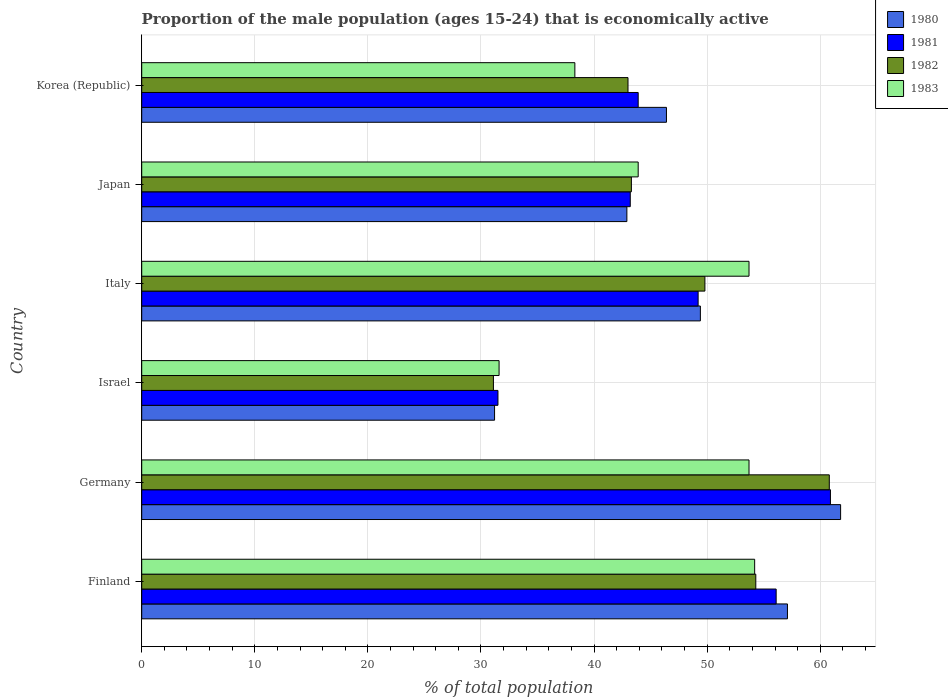How many groups of bars are there?
Ensure brevity in your answer.  6. Are the number of bars per tick equal to the number of legend labels?
Provide a succinct answer. Yes. How many bars are there on the 2nd tick from the top?
Make the answer very short. 4. How many bars are there on the 3rd tick from the bottom?
Ensure brevity in your answer.  4. What is the label of the 4th group of bars from the top?
Your answer should be compact. Israel. In how many cases, is the number of bars for a given country not equal to the number of legend labels?
Keep it short and to the point. 0. Across all countries, what is the maximum proportion of the male population that is economically active in 1982?
Ensure brevity in your answer.  60.8. Across all countries, what is the minimum proportion of the male population that is economically active in 1983?
Your answer should be very brief. 31.6. In which country was the proportion of the male population that is economically active in 1983 minimum?
Ensure brevity in your answer.  Israel. What is the total proportion of the male population that is economically active in 1981 in the graph?
Make the answer very short. 284.8. What is the difference between the proportion of the male population that is economically active in 1982 in Italy and that in Korea (Republic)?
Your answer should be very brief. 6.8. What is the difference between the proportion of the male population that is economically active in 1980 in Israel and the proportion of the male population that is economically active in 1981 in Germany?
Keep it short and to the point. -29.7. What is the average proportion of the male population that is economically active in 1983 per country?
Provide a short and direct response. 45.9. What is the difference between the proportion of the male population that is economically active in 1980 and proportion of the male population that is economically active in 1981 in Finland?
Keep it short and to the point. 1. In how many countries, is the proportion of the male population that is economically active in 1982 greater than 34 %?
Keep it short and to the point. 5. What is the ratio of the proportion of the male population that is economically active in 1982 in Germany to that in Italy?
Offer a terse response. 1.22. Is the proportion of the male population that is economically active in 1980 in Germany less than that in Italy?
Offer a terse response. No. Is the difference between the proportion of the male population that is economically active in 1980 in Germany and Italy greater than the difference between the proportion of the male population that is economically active in 1981 in Germany and Italy?
Offer a very short reply. Yes. What is the difference between the highest and the second highest proportion of the male population that is economically active in 1982?
Give a very brief answer. 6.5. What is the difference between the highest and the lowest proportion of the male population that is economically active in 1982?
Provide a succinct answer. 29.7. Is the sum of the proportion of the male population that is economically active in 1983 in Finland and Japan greater than the maximum proportion of the male population that is economically active in 1982 across all countries?
Your answer should be very brief. Yes. Is it the case that in every country, the sum of the proportion of the male population that is economically active in 1982 and proportion of the male population that is economically active in 1983 is greater than the sum of proportion of the male population that is economically active in 1981 and proportion of the male population that is economically active in 1980?
Offer a terse response. No. What does the 4th bar from the top in Finland represents?
Ensure brevity in your answer.  1980. What does the 2nd bar from the bottom in Korea (Republic) represents?
Your answer should be very brief. 1981. How many bars are there?
Offer a very short reply. 24. Are all the bars in the graph horizontal?
Keep it short and to the point. Yes. What is the difference between two consecutive major ticks on the X-axis?
Give a very brief answer. 10. Are the values on the major ticks of X-axis written in scientific E-notation?
Your answer should be very brief. No. How many legend labels are there?
Offer a very short reply. 4. How are the legend labels stacked?
Offer a very short reply. Vertical. What is the title of the graph?
Ensure brevity in your answer.  Proportion of the male population (ages 15-24) that is economically active. What is the label or title of the X-axis?
Offer a very short reply. % of total population. What is the % of total population in 1980 in Finland?
Provide a succinct answer. 57.1. What is the % of total population of 1981 in Finland?
Provide a succinct answer. 56.1. What is the % of total population in 1982 in Finland?
Ensure brevity in your answer.  54.3. What is the % of total population in 1983 in Finland?
Offer a terse response. 54.2. What is the % of total population of 1980 in Germany?
Offer a very short reply. 61.8. What is the % of total population in 1981 in Germany?
Your response must be concise. 60.9. What is the % of total population of 1982 in Germany?
Make the answer very short. 60.8. What is the % of total population of 1983 in Germany?
Offer a very short reply. 53.7. What is the % of total population of 1980 in Israel?
Ensure brevity in your answer.  31.2. What is the % of total population of 1981 in Israel?
Offer a terse response. 31.5. What is the % of total population of 1982 in Israel?
Offer a terse response. 31.1. What is the % of total population in 1983 in Israel?
Provide a short and direct response. 31.6. What is the % of total population of 1980 in Italy?
Make the answer very short. 49.4. What is the % of total population of 1981 in Italy?
Your answer should be compact. 49.2. What is the % of total population of 1982 in Italy?
Provide a short and direct response. 49.8. What is the % of total population of 1983 in Italy?
Offer a terse response. 53.7. What is the % of total population of 1980 in Japan?
Your answer should be very brief. 42.9. What is the % of total population of 1981 in Japan?
Offer a very short reply. 43.2. What is the % of total population of 1982 in Japan?
Ensure brevity in your answer.  43.3. What is the % of total population in 1983 in Japan?
Provide a short and direct response. 43.9. What is the % of total population in 1980 in Korea (Republic)?
Your answer should be compact. 46.4. What is the % of total population in 1981 in Korea (Republic)?
Offer a very short reply. 43.9. What is the % of total population in 1982 in Korea (Republic)?
Give a very brief answer. 43. What is the % of total population in 1983 in Korea (Republic)?
Offer a terse response. 38.3. Across all countries, what is the maximum % of total population of 1980?
Provide a succinct answer. 61.8. Across all countries, what is the maximum % of total population in 1981?
Provide a short and direct response. 60.9. Across all countries, what is the maximum % of total population in 1982?
Ensure brevity in your answer.  60.8. Across all countries, what is the maximum % of total population in 1983?
Keep it short and to the point. 54.2. Across all countries, what is the minimum % of total population in 1980?
Provide a short and direct response. 31.2. Across all countries, what is the minimum % of total population in 1981?
Make the answer very short. 31.5. Across all countries, what is the minimum % of total population of 1982?
Provide a succinct answer. 31.1. Across all countries, what is the minimum % of total population in 1983?
Provide a succinct answer. 31.6. What is the total % of total population in 1980 in the graph?
Provide a succinct answer. 288.8. What is the total % of total population in 1981 in the graph?
Offer a very short reply. 284.8. What is the total % of total population in 1982 in the graph?
Your response must be concise. 282.3. What is the total % of total population in 1983 in the graph?
Offer a very short reply. 275.4. What is the difference between the % of total population in 1980 in Finland and that in Germany?
Your answer should be very brief. -4.7. What is the difference between the % of total population in 1981 in Finland and that in Germany?
Your answer should be compact. -4.8. What is the difference between the % of total population of 1983 in Finland and that in Germany?
Your answer should be very brief. 0.5. What is the difference between the % of total population in 1980 in Finland and that in Israel?
Make the answer very short. 25.9. What is the difference between the % of total population of 1981 in Finland and that in Israel?
Make the answer very short. 24.6. What is the difference between the % of total population in 1982 in Finland and that in Israel?
Make the answer very short. 23.2. What is the difference between the % of total population in 1983 in Finland and that in Israel?
Keep it short and to the point. 22.6. What is the difference between the % of total population in 1982 in Finland and that in Italy?
Offer a terse response. 4.5. What is the difference between the % of total population in 1983 in Finland and that in Italy?
Offer a terse response. 0.5. What is the difference between the % of total population of 1980 in Finland and that in Korea (Republic)?
Ensure brevity in your answer.  10.7. What is the difference between the % of total population of 1981 in Finland and that in Korea (Republic)?
Offer a terse response. 12.2. What is the difference between the % of total population of 1980 in Germany and that in Israel?
Provide a short and direct response. 30.6. What is the difference between the % of total population in 1981 in Germany and that in Israel?
Provide a succinct answer. 29.4. What is the difference between the % of total population in 1982 in Germany and that in Israel?
Give a very brief answer. 29.7. What is the difference between the % of total population in 1983 in Germany and that in Israel?
Your answer should be compact. 22.1. What is the difference between the % of total population in 1980 in Germany and that in Italy?
Provide a short and direct response. 12.4. What is the difference between the % of total population in 1982 in Germany and that in Italy?
Provide a succinct answer. 11. What is the difference between the % of total population in 1983 in Germany and that in Italy?
Give a very brief answer. 0. What is the difference between the % of total population in 1982 in Germany and that in Japan?
Your answer should be very brief. 17.5. What is the difference between the % of total population in 1983 in Germany and that in Japan?
Your response must be concise. 9.8. What is the difference between the % of total population in 1980 in Germany and that in Korea (Republic)?
Provide a succinct answer. 15.4. What is the difference between the % of total population in 1982 in Germany and that in Korea (Republic)?
Give a very brief answer. 17.8. What is the difference between the % of total population of 1980 in Israel and that in Italy?
Provide a short and direct response. -18.2. What is the difference between the % of total population of 1981 in Israel and that in Italy?
Offer a very short reply. -17.7. What is the difference between the % of total population in 1982 in Israel and that in Italy?
Your response must be concise. -18.7. What is the difference between the % of total population of 1983 in Israel and that in Italy?
Ensure brevity in your answer.  -22.1. What is the difference between the % of total population in 1981 in Israel and that in Japan?
Provide a short and direct response. -11.7. What is the difference between the % of total population of 1982 in Israel and that in Japan?
Your answer should be very brief. -12.2. What is the difference between the % of total population of 1983 in Israel and that in Japan?
Provide a succinct answer. -12.3. What is the difference between the % of total population in 1980 in Israel and that in Korea (Republic)?
Ensure brevity in your answer.  -15.2. What is the difference between the % of total population of 1981 in Israel and that in Korea (Republic)?
Your answer should be compact. -12.4. What is the difference between the % of total population in 1982 in Israel and that in Korea (Republic)?
Your response must be concise. -11.9. What is the difference between the % of total population in 1981 in Italy and that in Japan?
Provide a succinct answer. 6. What is the difference between the % of total population in 1982 in Italy and that in Japan?
Provide a short and direct response. 6.5. What is the difference between the % of total population of 1980 in Italy and that in Korea (Republic)?
Your answer should be very brief. 3. What is the difference between the % of total population of 1981 in Italy and that in Korea (Republic)?
Provide a succinct answer. 5.3. What is the difference between the % of total population in 1980 in Japan and that in Korea (Republic)?
Offer a terse response. -3.5. What is the difference between the % of total population of 1981 in Japan and that in Korea (Republic)?
Offer a very short reply. -0.7. What is the difference between the % of total population of 1980 in Finland and the % of total population of 1981 in Germany?
Your answer should be very brief. -3.8. What is the difference between the % of total population of 1982 in Finland and the % of total population of 1983 in Germany?
Your answer should be compact. 0.6. What is the difference between the % of total population in 1980 in Finland and the % of total population in 1981 in Israel?
Give a very brief answer. 25.6. What is the difference between the % of total population of 1980 in Finland and the % of total population of 1982 in Israel?
Your response must be concise. 26. What is the difference between the % of total population of 1980 in Finland and the % of total population of 1983 in Israel?
Make the answer very short. 25.5. What is the difference between the % of total population of 1981 in Finland and the % of total population of 1983 in Israel?
Offer a very short reply. 24.5. What is the difference between the % of total population in 1982 in Finland and the % of total population in 1983 in Israel?
Ensure brevity in your answer.  22.7. What is the difference between the % of total population in 1982 in Finland and the % of total population in 1983 in Italy?
Give a very brief answer. 0.6. What is the difference between the % of total population in 1982 in Finland and the % of total population in 1983 in Japan?
Your response must be concise. 10.4. What is the difference between the % of total population in 1980 in Finland and the % of total population in 1981 in Korea (Republic)?
Your answer should be very brief. 13.2. What is the difference between the % of total population in 1982 in Finland and the % of total population in 1983 in Korea (Republic)?
Provide a succinct answer. 16. What is the difference between the % of total population in 1980 in Germany and the % of total population in 1981 in Israel?
Ensure brevity in your answer.  30.3. What is the difference between the % of total population of 1980 in Germany and the % of total population of 1982 in Israel?
Your response must be concise. 30.7. What is the difference between the % of total population in 1980 in Germany and the % of total population in 1983 in Israel?
Ensure brevity in your answer.  30.2. What is the difference between the % of total population in 1981 in Germany and the % of total population in 1982 in Israel?
Offer a terse response. 29.8. What is the difference between the % of total population of 1981 in Germany and the % of total population of 1983 in Israel?
Your answer should be compact. 29.3. What is the difference between the % of total population of 1982 in Germany and the % of total population of 1983 in Israel?
Make the answer very short. 29.2. What is the difference between the % of total population in 1980 in Germany and the % of total population in 1983 in Italy?
Make the answer very short. 8.1. What is the difference between the % of total population in 1981 in Germany and the % of total population in 1983 in Italy?
Provide a succinct answer. 7.2. What is the difference between the % of total population of 1980 in Germany and the % of total population of 1981 in Japan?
Offer a very short reply. 18.6. What is the difference between the % of total population in 1980 in Germany and the % of total population in 1982 in Japan?
Your answer should be compact. 18.5. What is the difference between the % of total population of 1980 in Germany and the % of total population of 1981 in Korea (Republic)?
Your answer should be very brief. 17.9. What is the difference between the % of total population of 1981 in Germany and the % of total population of 1982 in Korea (Republic)?
Give a very brief answer. 17.9. What is the difference between the % of total population in 1981 in Germany and the % of total population in 1983 in Korea (Republic)?
Your answer should be compact. 22.6. What is the difference between the % of total population in 1980 in Israel and the % of total population in 1981 in Italy?
Your response must be concise. -18. What is the difference between the % of total population in 1980 in Israel and the % of total population in 1982 in Italy?
Ensure brevity in your answer.  -18.6. What is the difference between the % of total population of 1980 in Israel and the % of total population of 1983 in Italy?
Offer a terse response. -22.5. What is the difference between the % of total population of 1981 in Israel and the % of total population of 1982 in Italy?
Ensure brevity in your answer.  -18.3. What is the difference between the % of total population in 1981 in Israel and the % of total population in 1983 in Italy?
Offer a very short reply. -22.2. What is the difference between the % of total population in 1982 in Israel and the % of total population in 1983 in Italy?
Keep it short and to the point. -22.6. What is the difference between the % of total population of 1980 in Israel and the % of total population of 1982 in Japan?
Offer a terse response. -12.1. What is the difference between the % of total population in 1981 in Israel and the % of total population in 1983 in Japan?
Your response must be concise. -12.4. What is the difference between the % of total population of 1980 in Israel and the % of total population of 1981 in Korea (Republic)?
Your answer should be compact. -12.7. What is the difference between the % of total population in 1980 in Israel and the % of total population in 1982 in Korea (Republic)?
Provide a succinct answer. -11.8. What is the difference between the % of total population in 1980 in Israel and the % of total population in 1983 in Korea (Republic)?
Give a very brief answer. -7.1. What is the difference between the % of total population of 1981 in Israel and the % of total population of 1982 in Korea (Republic)?
Your response must be concise. -11.5. What is the difference between the % of total population in 1981 in Israel and the % of total population in 1983 in Korea (Republic)?
Provide a succinct answer. -6.8. What is the difference between the % of total population of 1981 in Italy and the % of total population of 1982 in Japan?
Keep it short and to the point. 5.9. What is the difference between the % of total population of 1980 in Italy and the % of total population of 1981 in Korea (Republic)?
Provide a short and direct response. 5.5. What is the difference between the % of total population in 1980 in Italy and the % of total population in 1982 in Korea (Republic)?
Ensure brevity in your answer.  6.4. What is the difference between the % of total population of 1980 in Italy and the % of total population of 1983 in Korea (Republic)?
Give a very brief answer. 11.1. What is the difference between the % of total population in 1981 in Italy and the % of total population in 1983 in Korea (Republic)?
Give a very brief answer. 10.9. What is the difference between the % of total population of 1980 in Japan and the % of total population of 1982 in Korea (Republic)?
Provide a short and direct response. -0.1. What is the difference between the % of total population of 1980 in Japan and the % of total population of 1983 in Korea (Republic)?
Provide a succinct answer. 4.6. What is the difference between the % of total population in 1981 in Japan and the % of total population in 1982 in Korea (Republic)?
Offer a very short reply. 0.2. What is the difference between the % of total population of 1981 in Japan and the % of total population of 1983 in Korea (Republic)?
Provide a succinct answer. 4.9. What is the difference between the % of total population of 1982 in Japan and the % of total population of 1983 in Korea (Republic)?
Give a very brief answer. 5. What is the average % of total population of 1980 per country?
Offer a terse response. 48.13. What is the average % of total population in 1981 per country?
Offer a terse response. 47.47. What is the average % of total population in 1982 per country?
Make the answer very short. 47.05. What is the average % of total population of 1983 per country?
Make the answer very short. 45.9. What is the difference between the % of total population of 1980 and % of total population of 1982 in Finland?
Your answer should be very brief. 2.8. What is the difference between the % of total population of 1980 and % of total population of 1983 in Finland?
Your answer should be compact. 2.9. What is the difference between the % of total population in 1981 and % of total population in 1982 in Finland?
Your answer should be very brief. 1.8. What is the difference between the % of total population in 1980 and % of total population in 1981 in Germany?
Make the answer very short. 0.9. What is the difference between the % of total population in 1980 and % of total population in 1983 in Germany?
Your answer should be very brief. 8.1. What is the difference between the % of total population of 1981 and % of total population of 1982 in Germany?
Provide a succinct answer. 0.1. What is the difference between the % of total population of 1980 and % of total population of 1982 in Israel?
Ensure brevity in your answer.  0.1. What is the difference between the % of total population in 1981 and % of total population in 1982 in Israel?
Ensure brevity in your answer.  0.4. What is the difference between the % of total population in 1980 and % of total population in 1983 in Italy?
Your answer should be compact. -4.3. What is the difference between the % of total population of 1981 and % of total population of 1982 in Italy?
Keep it short and to the point. -0.6. What is the difference between the % of total population in 1982 and % of total population in 1983 in Italy?
Your answer should be very brief. -3.9. What is the difference between the % of total population of 1980 and % of total population of 1983 in Japan?
Your answer should be very brief. -1. What is the difference between the % of total population in 1981 and % of total population in 1982 in Japan?
Give a very brief answer. -0.1. What is the difference between the % of total population of 1982 and % of total population of 1983 in Japan?
Ensure brevity in your answer.  -0.6. What is the difference between the % of total population of 1980 and % of total population of 1983 in Korea (Republic)?
Your answer should be very brief. 8.1. What is the difference between the % of total population of 1981 and % of total population of 1982 in Korea (Republic)?
Your answer should be very brief. 0.9. What is the difference between the % of total population in 1981 and % of total population in 1983 in Korea (Republic)?
Your answer should be very brief. 5.6. What is the ratio of the % of total population of 1980 in Finland to that in Germany?
Your response must be concise. 0.92. What is the ratio of the % of total population in 1981 in Finland to that in Germany?
Keep it short and to the point. 0.92. What is the ratio of the % of total population in 1982 in Finland to that in Germany?
Give a very brief answer. 0.89. What is the ratio of the % of total population of 1983 in Finland to that in Germany?
Ensure brevity in your answer.  1.01. What is the ratio of the % of total population of 1980 in Finland to that in Israel?
Your answer should be compact. 1.83. What is the ratio of the % of total population in 1981 in Finland to that in Israel?
Provide a short and direct response. 1.78. What is the ratio of the % of total population in 1982 in Finland to that in Israel?
Offer a terse response. 1.75. What is the ratio of the % of total population of 1983 in Finland to that in Israel?
Ensure brevity in your answer.  1.72. What is the ratio of the % of total population of 1980 in Finland to that in Italy?
Offer a very short reply. 1.16. What is the ratio of the % of total population in 1981 in Finland to that in Italy?
Provide a succinct answer. 1.14. What is the ratio of the % of total population in 1982 in Finland to that in Italy?
Your answer should be compact. 1.09. What is the ratio of the % of total population in 1983 in Finland to that in Italy?
Ensure brevity in your answer.  1.01. What is the ratio of the % of total population in 1980 in Finland to that in Japan?
Offer a terse response. 1.33. What is the ratio of the % of total population of 1981 in Finland to that in Japan?
Your response must be concise. 1.3. What is the ratio of the % of total population in 1982 in Finland to that in Japan?
Offer a very short reply. 1.25. What is the ratio of the % of total population in 1983 in Finland to that in Japan?
Make the answer very short. 1.23. What is the ratio of the % of total population of 1980 in Finland to that in Korea (Republic)?
Your response must be concise. 1.23. What is the ratio of the % of total population in 1981 in Finland to that in Korea (Republic)?
Make the answer very short. 1.28. What is the ratio of the % of total population in 1982 in Finland to that in Korea (Republic)?
Make the answer very short. 1.26. What is the ratio of the % of total population of 1983 in Finland to that in Korea (Republic)?
Your answer should be very brief. 1.42. What is the ratio of the % of total population in 1980 in Germany to that in Israel?
Your response must be concise. 1.98. What is the ratio of the % of total population in 1981 in Germany to that in Israel?
Your answer should be very brief. 1.93. What is the ratio of the % of total population of 1982 in Germany to that in Israel?
Provide a succinct answer. 1.96. What is the ratio of the % of total population of 1983 in Germany to that in Israel?
Keep it short and to the point. 1.7. What is the ratio of the % of total population of 1980 in Germany to that in Italy?
Keep it short and to the point. 1.25. What is the ratio of the % of total population of 1981 in Germany to that in Italy?
Provide a succinct answer. 1.24. What is the ratio of the % of total population of 1982 in Germany to that in Italy?
Offer a terse response. 1.22. What is the ratio of the % of total population in 1980 in Germany to that in Japan?
Ensure brevity in your answer.  1.44. What is the ratio of the % of total population in 1981 in Germany to that in Japan?
Keep it short and to the point. 1.41. What is the ratio of the % of total population in 1982 in Germany to that in Japan?
Offer a terse response. 1.4. What is the ratio of the % of total population in 1983 in Germany to that in Japan?
Offer a very short reply. 1.22. What is the ratio of the % of total population of 1980 in Germany to that in Korea (Republic)?
Ensure brevity in your answer.  1.33. What is the ratio of the % of total population in 1981 in Germany to that in Korea (Republic)?
Give a very brief answer. 1.39. What is the ratio of the % of total population in 1982 in Germany to that in Korea (Republic)?
Give a very brief answer. 1.41. What is the ratio of the % of total population in 1983 in Germany to that in Korea (Republic)?
Make the answer very short. 1.4. What is the ratio of the % of total population of 1980 in Israel to that in Italy?
Your answer should be compact. 0.63. What is the ratio of the % of total population in 1981 in Israel to that in Italy?
Ensure brevity in your answer.  0.64. What is the ratio of the % of total population of 1982 in Israel to that in Italy?
Offer a terse response. 0.62. What is the ratio of the % of total population of 1983 in Israel to that in Italy?
Provide a succinct answer. 0.59. What is the ratio of the % of total population of 1980 in Israel to that in Japan?
Your answer should be compact. 0.73. What is the ratio of the % of total population in 1981 in Israel to that in Japan?
Make the answer very short. 0.73. What is the ratio of the % of total population of 1982 in Israel to that in Japan?
Give a very brief answer. 0.72. What is the ratio of the % of total population in 1983 in Israel to that in Japan?
Offer a terse response. 0.72. What is the ratio of the % of total population in 1980 in Israel to that in Korea (Republic)?
Ensure brevity in your answer.  0.67. What is the ratio of the % of total population of 1981 in Israel to that in Korea (Republic)?
Give a very brief answer. 0.72. What is the ratio of the % of total population of 1982 in Israel to that in Korea (Republic)?
Your answer should be very brief. 0.72. What is the ratio of the % of total population in 1983 in Israel to that in Korea (Republic)?
Give a very brief answer. 0.83. What is the ratio of the % of total population in 1980 in Italy to that in Japan?
Make the answer very short. 1.15. What is the ratio of the % of total population of 1981 in Italy to that in Japan?
Provide a succinct answer. 1.14. What is the ratio of the % of total population in 1982 in Italy to that in Japan?
Provide a short and direct response. 1.15. What is the ratio of the % of total population of 1983 in Italy to that in Japan?
Provide a short and direct response. 1.22. What is the ratio of the % of total population of 1980 in Italy to that in Korea (Republic)?
Offer a very short reply. 1.06. What is the ratio of the % of total population in 1981 in Italy to that in Korea (Republic)?
Your answer should be very brief. 1.12. What is the ratio of the % of total population in 1982 in Italy to that in Korea (Republic)?
Your answer should be very brief. 1.16. What is the ratio of the % of total population in 1983 in Italy to that in Korea (Republic)?
Ensure brevity in your answer.  1.4. What is the ratio of the % of total population in 1980 in Japan to that in Korea (Republic)?
Ensure brevity in your answer.  0.92. What is the ratio of the % of total population in 1981 in Japan to that in Korea (Republic)?
Your answer should be compact. 0.98. What is the ratio of the % of total population in 1982 in Japan to that in Korea (Republic)?
Give a very brief answer. 1.01. What is the ratio of the % of total population of 1983 in Japan to that in Korea (Republic)?
Provide a succinct answer. 1.15. What is the difference between the highest and the second highest % of total population in 1980?
Provide a succinct answer. 4.7. What is the difference between the highest and the second highest % of total population of 1981?
Offer a very short reply. 4.8. What is the difference between the highest and the lowest % of total population in 1980?
Your answer should be compact. 30.6. What is the difference between the highest and the lowest % of total population of 1981?
Offer a terse response. 29.4. What is the difference between the highest and the lowest % of total population in 1982?
Your answer should be compact. 29.7. What is the difference between the highest and the lowest % of total population in 1983?
Make the answer very short. 22.6. 